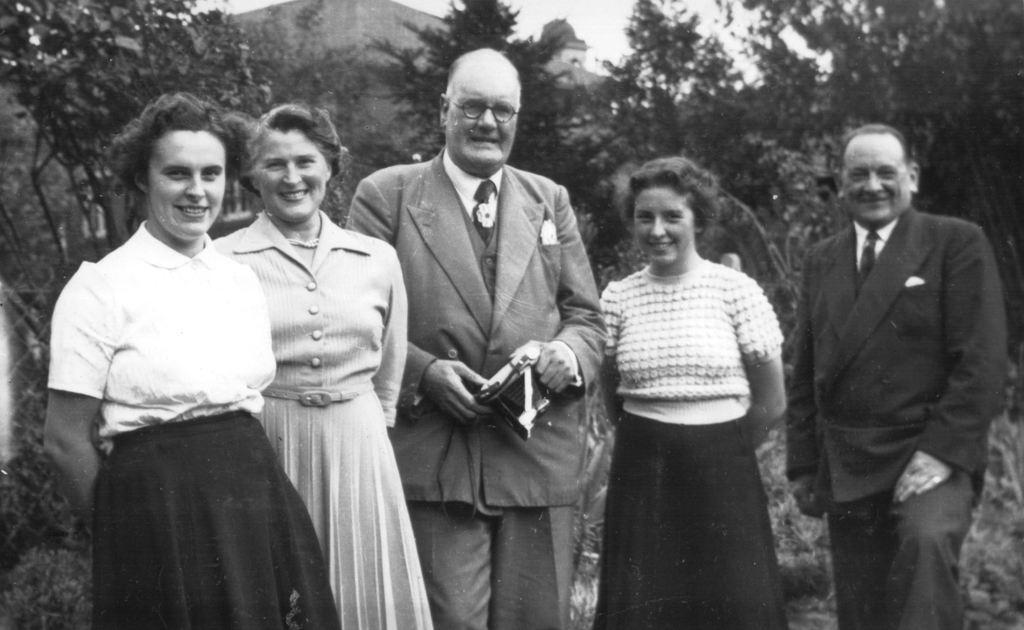Can you describe this image briefly? In this image there are four people in the foreground. There are trees and buildings in the background. And there is sky at the top. 